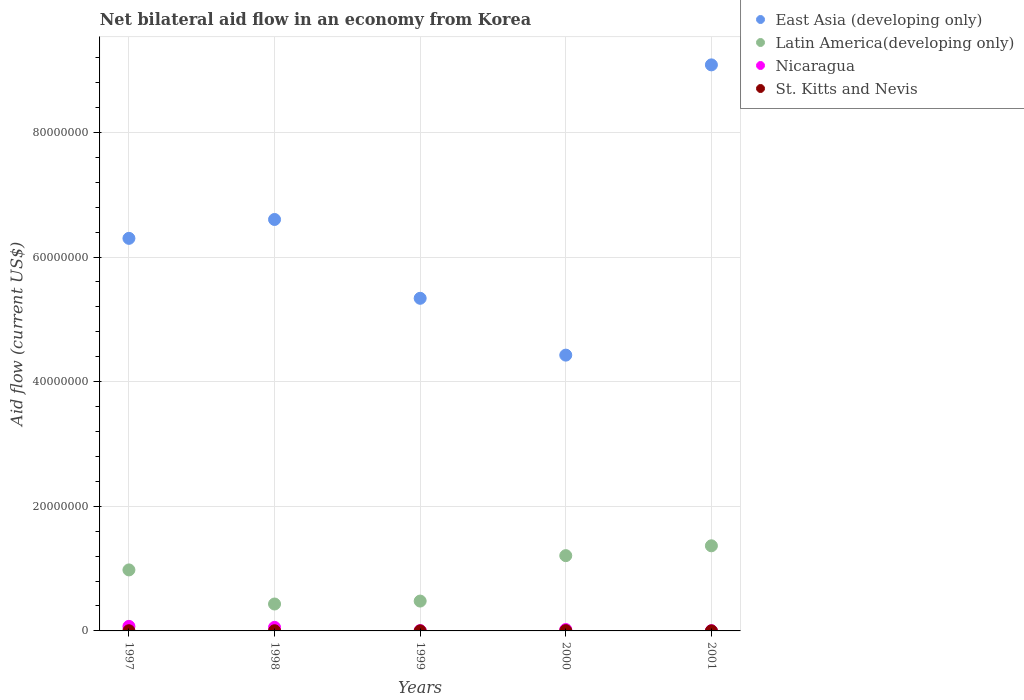Is the number of dotlines equal to the number of legend labels?
Ensure brevity in your answer.  Yes. What is the net bilateral aid flow in Latin America(developing only) in 1997?
Provide a short and direct response. 9.79e+06. Across all years, what is the maximum net bilateral aid flow in East Asia (developing only)?
Your response must be concise. 9.08e+07. In which year was the net bilateral aid flow in Latin America(developing only) maximum?
Keep it short and to the point. 2001. In which year was the net bilateral aid flow in Latin America(developing only) minimum?
Offer a terse response. 1998. What is the total net bilateral aid flow in East Asia (developing only) in the graph?
Offer a very short reply. 3.18e+08. What is the difference between the net bilateral aid flow in Latin America(developing only) in 1998 and that in 2000?
Give a very brief answer. -7.76e+06. What is the average net bilateral aid flow in St. Kitts and Nevis per year?
Provide a short and direct response. 2.60e+04. In the year 1999, what is the difference between the net bilateral aid flow in Nicaragua and net bilateral aid flow in St. Kitts and Nevis?
Your answer should be compact. 4.00e+04. In how many years, is the net bilateral aid flow in Latin America(developing only) greater than 24000000 US$?
Your answer should be compact. 0. What is the difference between the highest and the second highest net bilateral aid flow in Latin America(developing only)?
Your answer should be very brief. 1.58e+06. Is it the case that in every year, the sum of the net bilateral aid flow in East Asia (developing only) and net bilateral aid flow in Latin America(developing only)  is greater than the sum of net bilateral aid flow in Nicaragua and net bilateral aid flow in St. Kitts and Nevis?
Give a very brief answer. Yes. Does the net bilateral aid flow in St. Kitts and Nevis monotonically increase over the years?
Keep it short and to the point. No. Is the net bilateral aid flow in Nicaragua strictly greater than the net bilateral aid flow in Latin America(developing only) over the years?
Provide a succinct answer. No. What is the difference between two consecutive major ticks on the Y-axis?
Keep it short and to the point. 2.00e+07. Does the graph contain grids?
Ensure brevity in your answer.  Yes. Where does the legend appear in the graph?
Provide a succinct answer. Top right. How many legend labels are there?
Offer a very short reply. 4. What is the title of the graph?
Ensure brevity in your answer.  Net bilateral aid flow in an economy from Korea. Does "Italy" appear as one of the legend labels in the graph?
Your answer should be compact. No. What is the Aid flow (current US$) of East Asia (developing only) in 1997?
Provide a short and direct response. 6.30e+07. What is the Aid flow (current US$) of Latin America(developing only) in 1997?
Your answer should be very brief. 9.79e+06. What is the Aid flow (current US$) in Nicaragua in 1997?
Make the answer very short. 7.30e+05. What is the Aid flow (current US$) in East Asia (developing only) in 1998?
Your response must be concise. 6.60e+07. What is the Aid flow (current US$) in Latin America(developing only) in 1998?
Keep it short and to the point. 4.32e+06. What is the Aid flow (current US$) of Nicaragua in 1998?
Your answer should be compact. 5.70e+05. What is the Aid flow (current US$) of East Asia (developing only) in 1999?
Your answer should be compact. 5.34e+07. What is the Aid flow (current US$) of Latin America(developing only) in 1999?
Your answer should be very brief. 4.79e+06. What is the Aid flow (current US$) in Nicaragua in 1999?
Your answer should be compact. 5.00e+04. What is the Aid flow (current US$) of East Asia (developing only) in 2000?
Your response must be concise. 4.43e+07. What is the Aid flow (current US$) of Latin America(developing only) in 2000?
Provide a succinct answer. 1.21e+07. What is the Aid flow (current US$) in Nicaragua in 2000?
Offer a terse response. 2.20e+05. What is the Aid flow (current US$) in East Asia (developing only) in 2001?
Make the answer very short. 9.08e+07. What is the Aid flow (current US$) in Latin America(developing only) in 2001?
Offer a terse response. 1.37e+07. What is the Aid flow (current US$) in St. Kitts and Nevis in 2001?
Give a very brief answer. 10000. Across all years, what is the maximum Aid flow (current US$) of East Asia (developing only)?
Offer a terse response. 9.08e+07. Across all years, what is the maximum Aid flow (current US$) of Latin America(developing only)?
Provide a short and direct response. 1.37e+07. Across all years, what is the maximum Aid flow (current US$) in Nicaragua?
Your response must be concise. 7.30e+05. Across all years, what is the maximum Aid flow (current US$) of St. Kitts and Nevis?
Make the answer very short. 5.00e+04. Across all years, what is the minimum Aid flow (current US$) in East Asia (developing only)?
Your answer should be compact. 4.43e+07. Across all years, what is the minimum Aid flow (current US$) in Latin America(developing only)?
Ensure brevity in your answer.  4.32e+06. Across all years, what is the minimum Aid flow (current US$) in Nicaragua?
Offer a very short reply. 4.00e+04. Across all years, what is the minimum Aid flow (current US$) of St. Kitts and Nevis?
Make the answer very short. 10000. What is the total Aid flow (current US$) in East Asia (developing only) in the graph?
Provide a succinct answer. 3.18e+08. What is the total Aid flow (current US$) of Latin America(developing only) in the graph?
Offer a terse response. 4.46e+07. What is the total Aid flow (current US$) in Nicaragua in the graph?
Provide a short and direct response. 1.61e+06. What is the total Aid flow (current US$) in St. Kitts and Nevis in the graph?
Offer a terse response. 1.30e+05. What is the difference between the Aid flow (current US$) in East Asia (developing only) in 1997 and that in 1998?
Your answer should be compact. -3.03e+06. What is the difference between the Aid flow (current US$) in Latin America(developing only) in 1997 and that in 1998?
Your answer should be very brief. 5.47e+06. What is the difference between the Aid flow (current US$) of St. Kitts and Nevis in 1997 and that in 1998?
Ensure brevity in your answer.  0. What is the difference between the Aid flow (current US$) of East Asia (developing only) in 1997 and that in 1999?
Your answer should be compact. 9.62e+06. What is the difference between the Aid flow (current US$) of Latin America(developing only) in 1997 and that in 1999?
Your answer should be very brief. 5.00e+06. What is the difference between the Aid flow (current US$) in Nicaragua in 1997 and that in 1999?
Your answer should be compact. 6.80e+05. What is the difference between the Aid flow (current US$) of St. Kitts and Nevis in 1997 and that in 1999?
Ensure brevity in your answer.  2.00e+04. What is the difference between the Aid flow (current US$) in East Asia (developing only) in 1997 and that in 2000?
Keep it short and to the point. 1.87e+07. What is the difference between the Aid flow (current US$) in Latin America(developing only) in 1997 and that in 2000?
Provide a short and direct response. -2.29e+06. What is the difference between the Aid flow (current US$) in Nicaragua in 1997 and that in 2000?
Your answer should be very brief. 5.10e+05. What is the difference between the Aid flow (current US$) in St. Kitts and Nevis in 1997 and that in 2000?
Keep it short and to the point. -2.00e+04. What is the difference between the Aid flow (current US$) in East Asia (developing only) in 1997 and that in 2001?
Keep it short and to the point. -2.78e+07. What is the difference between the Aid flow (current US$) of Latin America(developing only) in 1997 and that in 2001?
Your answer should be compact. -3.87e+06. What is the difference between the Aid flow (current US$) of Nicaragua in 1997 and that in 2001?
Provide a short and direct response. 6.90e+05. What is the difference between the Aid flow (current US$) of St. Kitts and Nevis in 1997 and that in 2001?
Offer a terse response. 2.00e+04. What is the difference between the Aid flow (current US$) in East Asia (developing only) in 1998 and that in 1999?
Ensure brevity in your answer.  1.26e+07. What is the difference between the Aid flow (current US$) of Latin America(developing only) in 1998 and that in 1999?
Keep it short and to the point. -4.70e+05. What is the difference between the Aid flow (current US$) of Nicaragua in 1998 and that in 1999?
Your answer should be very brief. 5.20e+05. What is the difference between the Aid flow (current US$) in St. Kitts and Nevis in 1998 and that in 1999?
Keep it short and to the point. 2.00e+04. What is the difference between the Aid flow (current US$) in East Asia (developing only) in 1998 and that in 2000?
Provide a short and direct response. 2.18e+07. What is the difference between the Aid flow (current US$) of Latin America(developing only) in 1998 and that in 2000?
Provide a succinct answer. -7.76e+06. What is the difference between the Aid flow (current US$) in Nicaragua in 1998 and that in 2000?
Your answer should be very brief. 3.50e+05. What is the difference between the Aid flow (current US$) in St. Kitts and Nevis in 1998 and that in 2000?
Offer a very short reply. -2.00e+04. What is the difference between the Aid flow (current US$) of East Asia (developing only) in 1998 and that in 2001?
Ensure brevity in your answer.  -2.48e+07. What is the difference between the Aid flow (current US$) of Latin America(developing only) in 1998 and that in 2001?
Provide a short and direct response. -9.34e+06. What is the difference between the Aid flow (current US$) of Nicaragua in 1998 and that in 2001?
Make the answer very short. 5.30e+05. What is the difference between the Aid flow (current US$) in St. Kitts and Nevis in 1998 and that in 2001?
Your answer should be compact. 2.00e+04. What is the difference between the Aid flow (current US$) of East Asia (developing only) in 1999 and that in 2000?
Give a very brief answer. 9.12e+06. What is the difference between the Aid flow (current US$) of Latin America(developing only) in 1999 and that in 2000?
Your answer should be compact. -7.29e+06. What is the difference between the Aid flow (current US$) in St. Kitts and Nevis in 1999 and that in 2000?
Ensure brevity in your answer.  -4.00e+04. What is the difference between the Aid flow (current US$) in East Asia (developing only) in 1999 and that in 2001?
Ensure brevity in your answer.  -3.75e+07. What is the difference between the Aid flow (current US$) of Latin America(developing only) in 1999 and that in 2001?
Your answer should be very brief. -8.87e+06. What is the difference between the Aid flow (current US$) in Nicaragua in 1999 and that in 2001?
Provide a short and direct response. 10000. What is the difference between the Aid flow (current US$) in St. Kitts and Nevis in 1999 and that in 2001?
Keep it short and to the point. 0. What is the difference between the Aid flow (current US$) in East Asia (developing only) in 2000 and that in 2001?
Keep it short and to the point. -4.66e+07. What is the difference between the Aid flow (current US$) of Latin America(developing only) in 2000 and that in 2001?
Make the answer very short. -1.58e+06. What is the difference between the Aid flow (current US$) of Nicaragua in 2000 and that in 2001?
Make the answer very short. 1.80e+05. What is the difference between the Aid flow (current US$) of East Asia (developing only) in 1997 and the Aid flow (current US$) of Latin America(developing only) in 1998?
Provide a short and direct response. 5.87e+07. What is the difference between the Aid flow (current US$) in East Asia (developing only) in 1997 and the Aid flow (current US$) in Nicaragua in 1998?
Your answer should be compact. 6.24e+07. What is the difference between the Aid flow (current US$) in East Asia (developing only) in 1997 and the Aid flow (current US$) in St. Kitts and Nevis in 1998?
Make the answer very short. 6.30e+07. What is the difference between the Aid flow (current US$) in Latin America(developing only) in 1997 and the Aid flow (current US$) in Nicaragua in 1998?
Your response must be concise. 9.22e+06. What is the difference between the Aid flow (current US$) of Latin America(developing only) in 1997 and the Aid flow (current US$) of St. Kitts and Nevis in 1998?
Provide a succinct answer. 9.76e+06. What is the difference between the Aid flow (current US$) in East Asia (developing only) in 1997 and the Aid flow (current US$) in Latin America(developing only) in 1999?
Your response must be concise. 5.82e+07. What is the difference between the Aid flow (current US$) in East Asia (developing only) in 1997 and the Aid flow (current US$) in Nicaragua in 1999?
Make the answer very short. 6.30e+07. What is the difference between the Aid flow (current US$) in East Asia (developing only) in 1997 and the Aid flow (current US$) in St. Kitts and Nevis in 1999?
Make the answer very short. 6.30e+07. What is the difference between the Aid flow (current US$) of Latin America(developing only) in 1997 and the Aid flow (current US$) of Nicaragua in 1999?
Keep it short and to the point. 9.74e+06. What is the difference between the Aid flow (current US$) of Latin America(developing only) in 1997 and the Aid flow (current US$) of St. Kitts and Nevis in 1999?
Give a very brief answer. 9.78e+06. What is the difference between the Aid flow (current US$) in Nicaragua in 1997 and the Aid flow (current US$) in St. Kitts and Nevis in 1999?
Offer a very short reply. 7.20e+05. What is the difference between the Aid flow (current US$) of East Asia (developing only) in 1997 and the Aid flow (current US$) of Latin America(developing only) in 2000?
Keep it short and to the point. 5.09e+07. What is the difference between the Aid flow (current US$) in East Asia (developing only) in 1997 and the Aid flow (current US$) in Nicaragua in 2000?
Offer a very short reply. 6.28e+07. What is the difference between the Aid flow (current US$) of East Asia (developing only) in 1997 and the Aid flow (current US$) of St. Kitts and Nevis in 2000?
Your response must be concise. 6.30e+07. What is the difference between the Aid flow (current US$) of Latin America(developing only) in 1997 and the Aid flow (current US$) of Nicaragua in 2000?
Provide a succinct answer. 9.57e+06. What is the difference between the Aid flow (current US$) in Latin America(developing only) in 1997 and the Aid flow (current US$) in St. Kitts and Nevis in 2000?
Give a very brief answer. 9.74e+06. What is the difference between the Aid flow (current US$) in Nicaragua in 1997 and the Aid flow (current US$) in St. Kitts and Nevis in 2000?
Provide a short and direct response. 6.80e+05. What is the difference between the Aid flow (current US$) in East Asia (developing only) in 1997 and the Aid flow (current US$) in Latin America(developing only) in 2001?
Offer a terse response. 4.93e+07. What is the difference between the Aid flow (current US$) of East Asia (developing only) in 1997 and the Aid flow (current US$) of Nicaragua in 2001?
Make the answer very short. 6.30e+07. What is the difference between the Aid flow (current US$) of East Asia (developing only) in 1997 and the Aid flow (current US$) of St. Kitts and Nevis in 2001?
Your response must be concise. 6.30e+07. What is the difference between the Aid flow (current US$) in Latin America(developing only) in 1997 and the Aid flow (current US$) in Nicaragua in 2001?
Your response must be concise. 9.75e+06. What is the difference between the Aid flow (current US$) of Latin America(developing only) in 1997 and the Aid flow (current US$) of St. Kitts and Nevis in 2001?
Offer a very short reply. 9.78e+06. What is the difference between the Aid flow (current US$) of Nicaragua in 1997 and the Aid flow (current US$) of St. Kitts and Nevis in 2001?
Provide a succinct answer. 7.20e+05. What is the difference between the Aid flow (current US$) in East Asia (developing only) in 1998 and the Aid flow (current US$) in Latin America(developing only) in 1999?
Your answer should be compact. 6.12e+07. What is the difference between the Aid flow (current US$) of East Asia (developing only) in 1998 and the Aid flow (current US$) of Nicaragua in 1999?
Provide a succinct answer. 6.60e+07. What is the difference between the Aid flow (current US$) of East Asia (developing only) in 1998 and the Aid flow (current US$) of St. Kitts and Nevis in 1999?
Give a very brief answer. 6.60e+07. What is the difference between the Aid flow (current US$) in Latin America(developing only) in 1998 and the Aid flow (current US$) in Nicaragua in 1999?
Your answer should be compact. 4.27e+06. What is the difference between the Aid flow (current US$) of Latin America(developing only) in 1998 and the Aid flow (current US$) of St. Kitts and Nevis in 1999?
Keep it short and to the point. 4.31e+06. What is the difference between the Aid flow (current US$) in Nicaragua in 1998 and the Aid flow (current US$) in St. Kitts and Nevis in 1999?
Keep it short and to the point. 5.60e+05. What is the difference between the Aid flow (current US$) in East Asia (developing only) in 1998 and the Aid flow (current US$) in Latin America(developing only) in 2000?
Provide a short and direct response. 5.40e+07. What is the difference between the Aid flow (current US$) of East Asia (developing only) in 1998 and the Aid flow (current US$) of Nicaragua in 2000?
Offer a very short reply. 6.58e+07. What is the difference between the Aid flow (current US$) in East Asia (developing only) in 1998 and the Aid flow (current US$) in St. Kitts and Nevis in 2000?
Keep it short and to the point. 6.60e+07. What is the difference between the Aid flow (current US$) of Latin America(developing only) in 1998 and the Aid flow (current US$) of Nicaragua in 2000?
Offer a very short reply. 4.10e+06. What is the difference between the Aid flow (current US$) of Latin America(developing only) in 1998 and the Aid flow (current US$) of St. Kitts and Nevis in 2000?
Your response must be concise. 4.27e+06. What is the difference between the Aid flow (current US$) of Nicaragua in 1998 and the Aid flow (current US$) of St. Kitts and Nevis in 2000?
Ensure brevity in your answer.  5.20e+05. What is the difference between the Aid flow (current US$) of East Asia (developing only) in 1998 and the Aid flow (current US$) of Latin America(developing only) in 2001?
Your answer should be very brief. 5.24e+07. What is the difference between the Aid flow (current US$) of East Asia (developing only) in 1998 and the Aid flow (current US$) of Nicaragua in 2001?
Provide a succinct answer. 6.60e+07. What is the difference between the Aid flow (current US$) of East Asia (developing only) in 1998 and the Aid flow (current US$) of St. Kitts and Nevis in 2001?
Give a very brief answer. 6.60e+07. What is the difference between the Aid flow (current US$) of Latin America(developing only) in 1998 and the Aid flow (current US$) of Nicaragua in 2001?
Ensure brevity in your answer.  4.28e+06. What is the difference between the Aid flow (current US$) of Latin America(developing only) in 1998 and the Aid flow (current US$) of St. Kitts and Nevis in 2001?
Ensure brevity in your answer.  4.31e+06. What is the difference between the Aid flow (current US$) of Nicaragua in 1998 and the Aid flow (current US$) of St. Kitts and Nevis in 2001?
Provide a succinct answer. 5.60e+05. What is the difference between the Aid flow (current US$) in East Asia (developing only) in 1999 and the Aid flow (current US$) in Latin America(developing only) in 2000?
Offer a terse response. 4.13e+07. What is the difference between the Aid flow (current US$) of East Asia (developing only) in 1999 and the Aid flow (current US$) of Nicaragua in 2000?
Give a very brief answer. 5.32e+07. What is the difference between the Aid flow (current US$) in East Asia (developing only) in 1999 and the Aid flow (current US$) in St. Kitts and Nevis in 2000?
Provide a succinct answer. 5.33e+07. What is the difference between the Aid flow (current US$) of Latin America(developing only) in 1999 and the Aid flow (current US$) of Nicaragua in 2000?
Ensure brevity in your answer.  4.57e+06. What is the difference between the Aid flow (current US$) in Latin America(developing only) in 1999 and the Aid flow (current US$) in St. Kitts and Nevis in 2000?
Your answer should be compact. 4.74e+06. What is the difference between the Aid flow (current US$) of East Asia (developing only) in 1999 and the Aid flow (current US$) of Latin America(developing only) in 2001?
Your answer should be compact. 3.97e+07. What is the difference between the Aid flow (current US$) of East Asia (developing only) in 1999 and the Aid flow (current US$) of Nicaragua in 2001?
Provide a succinct answer. 5.33e+07. What is the difference between the Aid flow (current US$) in East Asia (developing only) in 1999 and the Aid flow (current US$) in St. Kitts and Nevis in 2001?
Give a very brief answer. 5.34e+07. What is the difference between the Aid flow (current US$) in Latin America(developing only) in 1999 and the Aid flow (current US$) in Nicaragua in 2001?
Offer a terse response. 4.75e+06. What is the difference between the Aid flow (current US$) of Latin America(developing only) in 1999 and the Aid flow (current US$) of St. Kitts and Nevis in 2001?
Provide a short and direct response. 4.78e+06. What is the difference between the Aid flow (current US$) of East Asia (developing only) in 2000 and the Aid flow (current US$) of Latin America(developing only) in 2001?
Make the answer very short. 3.06e+07. What is the difference between the Aid flow (current US$) in East Asia (developing only) in 2000 and the Aid flow (current US$) in Nicaragua in 2001?
Offer a very short reply. 4.42e+07. What is the difference between the Aid flow (current US$) of East Asia (developing only) in 2000 and the Aid flow (current US$) of St. Kitts and Nevis in 2001?
Provide a short and direct response. 4.42e+07. What is the difference between the Aid flow (current US$) of Latin America(developing only) in 2000 and the Aid flow (current US$) of Nicaragua in 2001?
Your response must be concise. 1.20e+07. What is the difference between the Aid flow (current US$) in Latin America(developing only) in 2000 and the Aid flow (current US$) in St. Kitts and Nevis in 2001?
Make the answer very short. 1.21e+07. What is the average Aid flow (current US$) in East Asia (developing only) per year?
Your answer should be very brief. 6.35e+07. What is the average Aid flow (current US$) of Latin America(developing only) per year?
Keep it short and to the point. 8.93e+06. What is the average Aid flow (current US$) in Nicaragua per year?
Your answer should be very brief. 3.22e+05. What is the average Aid flow (current US$) in St. Kitts and Nevis per year?
Your answer should be compact. 2.60e+04. In the year 1997, what is the difference between the Aid flow (current US$) of East Asia (developing only) and Aid flow (current US$) of Latin America(developing only)?
Provide a succinct answer. 5.32e+07. In the year 1997, what is the difference between the Aid flow (current US$) of East Asia (developing only) and Aid flow (current US$) of Nicaragua?
Provide a short and direct response. 6.23e+07. In the year 1997, what is the difference between the Aid flow (current US$) in East Asia (developing only) and Aid flow (current US$) in St. Kitts and Nevis?
Give a very brief answer. 6.30e+07. In the year 1997, what is the difference between the Aid flow (current US$) of Latin America(developing only) and Aid flow (current US$) of Nicaragua?
Your answer should be very brief. 9.06e+06. In the year 1997, what is the difference between the Aid flow (current US$) of Latin America(developing only) and Aid flow (current US$) of St. Kitts and Nevis?
Your answer should be very brief. 9.76e+06. In the year 1998, what is the difference between the Aid flow (current US$) in East Asia (developing only) and Aid flow (current US$) in Latin America(developing only)?
Your answer should be compact. 6.17e+07. In the year 1998, what is the difference between the Aid flow (current US$) in East Asia (developing only) and Aid flow (current US$) in Nicaragua?
Keep it short and to the point. 6.55e+07. In the year 1998, what is the difference between the Aid flow (current US$) in East Asia (developing only) and Aid flow (current US$) in St. Kitts and Nevis?
Your answer should be very brief. 6.60e+07. In the year 1998, what is the difference between the Aid flow (current US$) in Latin America(developing only) and Aid flow (current US$) in Nicaragua?
Offer a terse response. 3.75e+06. In the year 1998, what is the difference between the Aid flow (current US$) in Latin America(developing only) and Aid flow (current US$) in St. Kitts and Nevis?
Provide a short and direct response. 4.29e+06. In the year 1998, what is the difference between the Aid flow (current US$) in Nicaragua and Aid flow (current US$) in St. Kitts and Nevis?
Offer a very short reply. 5.40e+05. In the year 1999, what is the difference between the Aid flow (current US$) of East Asia (developing only) and Aid flow (current US$) of Latin America(developing only)?
Your response must be concise. 4.86e+07. In the year 1999, what is the difference between the Aid flow (current US$) of East Asia (developing only) and Aid flow (current US$) of Nicaragua?
Your response must be concise. 5.33e+07. In the year 1999, what is the difference between the Aid flow (current US$) of East Asia (developing only) and Aid flow (current US$) of St. Kitts and Nevis?
Provide a short and direct response. 5.34e+07. In the year 1999, what is the difference between the Aid flow (current US$) of Latin America(developing only) and Aid flow (current US$) of Nicaragua?
Give a very brief answer. 4.74e+06. In the year 1999, what is the difference between the Aid flow (current US$) in Latin America(developing only) and Aid flow (current US$) in St. Kitts and Nevis?
Offer a very short reply. 4.78e+06. In the year 1999, what is the difference between the Aid flow (current US$) in Nicaragua and Aid flow (current US$) in St. Kitts and Nevis?
Provide a short and direct response. 4.00e+04. In the year 2000, what is the difference between the Aid flow (current US$) in East Asia (developing only) and Aid flow (current US$) in Latin America(developing only)?
Keep it short and to the point. 3.22e+07. In the year 2000, what is the difference between the Aid flow (current US$) of East Asia (developing only) and Aid flow (current US$) of Nicaragua?
Offer a terse response. 4.40e+07. In the year 2000, what is the difference between the Aid flow (current US$) in East Asia (developing only) and Aid flow (current US$) in St. Kitts and Nevis?
Give a very brief answer. 4.42e+07. In the year 2000, what is the difference between the Aid flow (current US$) of Latin America(developing only) and Aid flow (current US$) of Nicaragua?
Keep it short and to the point. 1.19e+07. In the year 2000, what is the difference between the Aid flow (current US$) of Latin America(developing only) and Aid flow (current US$) of St. Kitts and Nevis?
Give a very brief answer. 1.20e+07. In the year 2001, what is the difference between the Aid flow (current US$) of East Asia (developing only) and Aid flow (current US$) of Latin America(developing only)?
Ensure brevity in your answer.  7.72e+07. In the year 2001, what is the difference between the Aid flow (current US$) of East Asia (developing only) and Aid flow (current US$) of Nicaragua?
Keep it short and to the point. 9.08e+07. In the year 2001, what is the difference between the Aid flow (current US$) of East Asia (developing only) and Aid flow (current US$) of St. Kitts and Nevis?
Provide a succinct answer. 9.08e+07. In the year 2001, what is the difference between the Aid flow (current US$) in Latin America(developing only) and Aid flow (current US$) in Nicaragua?
Your answer should be very brief. 1.36e+07. In the year 2001, what is the difference between the Aid flow (current US$) in Latin America(developing only) and Aid flow (current US$) in St. Kitts and Nevis?
Offer a very short reply. 1.36e+07. In the year 2001, what is the difference between the Aid flow (current US$) of Nicaragua and Aid flow (current US$) of St. Kitts and Nevis?
Your answer should be very brief. 3.00e+04. What is the ratio of the Aid flow (current US$) of East Asia (developing only) in 1997 to that in 1998?
Your response must be concise. 0.95. What is the ratio of the Aid flow (current US$) in Latin America(developing only) in 1997 to that in 1998?
Give a very brief answer. 2.27. What is the ratio of the Aid flow (current US$) of Nicaragua in 1997 to that in 1998?
Ensure brevity in your answer.  1.28. What is the ratio of the Aid flow (current US$) of St. Kitts and Nevis in 1997 to that in 1998?
Offer a terse response. 1. What is the ratio of the Aid flow (current US$) of East Asia (developing only) in 1997 to that in 1999?
Offer a terse response. 1.18. What is the ratio of the Aid flow (current US$) of Latin America(developing only) in 1997 to that in 1999?
Provide a short and direct response. 2.04. What is the ratio of the Aid flow (current US$) in Nicaragua in 1997 to that in 1999?
Your answer should be very brief. 14.6. What is the ratio of the Aid flow (current US$) of St. Kitts and Nevis in 1997 to that in 1999?
Provide a succinct answer. 3. What is the ratio of the Aid flow (current US$) of East Asia (developing only) in 1997 to that in 2000?
Provide a short and direct response. 1.42. What is the ratio of the Aid flow (current US$) of Latin America(developing only) in 1997 to that in 2000?
Make the answer very short. 0.81. What is the ratio of the Aid flow (current US$) of Nicaragua in 1997 to that in 2000?
Your response must be concise. 3.32. What is the ratio of the Aid flow (current US$) in East Asia (developing only) in 1997 to that in 2001?
Your answer should be compact. 0.69. What is the ratio of the Aid flow (current US$) of Latin America(developing only) in 1997 to that in 2001?
Your answer should be compact. 0.72. What is the ratio of the Aid flow (current US$) in Nicaragua in 1997 to that in 2001?
Your answer should be compact. 18.25. What is the ratio of the Aid flow (current US$) of East Asia (developing only) in 1998 to that in 1999?
Make the answer very short. 1.24. What is the ratio of the Aid flow (current US$) of Latin America(developing only) in 1998 to that in 1999?
Your answer should be very brief. 0.9. What is the ratio of the Aid flow (current US$) of Nicaragua in 1998 to that in 1999?
Your answer should be very brief. 11.4. What is the ratio of the Aid flow (current US$) in St. Kitts and Nevis in 1998 to that in 1999?
Offer a terse response. 3. What is the ratio of the Aid flow (current US$) of East Asia (developing only) in 1998 to that in 2000?
Your response must be concise. 1.49. What is the ratio of the Aid flow (current US$) in Latin America(developing only) in 1998 to that in 2000?
Make the answer very short. 0.36. What is the ratio of the Aid flow (current US$) in Nicaragua in 1998 to that in 2000?
Offer a terse response. 2.59. What is the ratio of the Aid flow (current US$) in East Asia (developing only) in 1998 to that in 2001?
Give a very brief answer. 0.73. What is the ratio of the Aid flow (current US$) in Latin America(developing only) in 1998 to that in 2001?
Make the answer very short. 0.32. What is the ratio of the Aid flow (current US$) of Nicaragua in 1998 to that in 2001?
Offer a terse response. 14.25. What is the ratio of the Aid flow (current US$) in St. Kitts and Nevis in 1998 to that in 2001?
Keep it short and to the point. 3. What is the ratio of the Aid flow (current US$) in East Asia (developing only) in 1999 to that in 2000?
Your response must be concise. 1.21. What is the ratio of the Aid flow (current US$) in Latin America(developing only) in 1999 to that in 2000?
Offer a very short reply. 0.4. What is the ratio of the Aid flow (current US$) in Nicaragua in 1999 to that in 2000?
Provide a succinct answer. 0.23. What is the ratio of the Aid flow (current US$) in East Asia (developing only) in 1999 to that in 2001?
Provide a succinct answer. 0.59. What is the ratio of the Aid flow (current US$) of Latin America(developing only) in 1999 to that in 2001?
Provide a short and direct response. 0.35. What is the ratio of the Aid flow (current US$) of St. Kitts and Nevis in 1999 to that in 2001?
Provide a succinct answer. 1. What is the ratio of the Aid flow (current US$) in East Asia (developing only) in 2000 to that in 2001?
Your response must be concise. 0.49. What is the ratio of the Aid flow (current US$) in Latin America(developing only) in 2000 to that in 2001?
Give a very brief answer. 0.88. What is the ratio of the Aid flow (current US$) of St. Kitts and Nevis in 2000 to that in 2001?
Your answer should be compact. 5. What is the difference between the highest and the second highest Aid flow (current US$) of East Asia (developing only)?
Make the answer very short. 2.48e+07. What is the difference between the highest and the second highest Aid flow (current US$) of Latin America(developing only)?
Your answer should be compact. 1.58e+06. What is the difference between the highest and the second highest Aid flow (current US$) of St. Kitts and Nevis?
Provide a short and direct response. 2.00e+04. What is the difference between the highest and the lowest Aid flow (current US$) in East Asia (developing only)?
Offer a terse response. 4.66e+07. What is the difference between the highest and the lowest Aid flow (current US$) in Latin America(developing only)?
Ensure brevity in your answer.  9.34e+06. What is the difference between the highest and the lowest Aid flow (current US$) of Nicaragua?
Ensure brevity in your answer.  6.90e+05. 